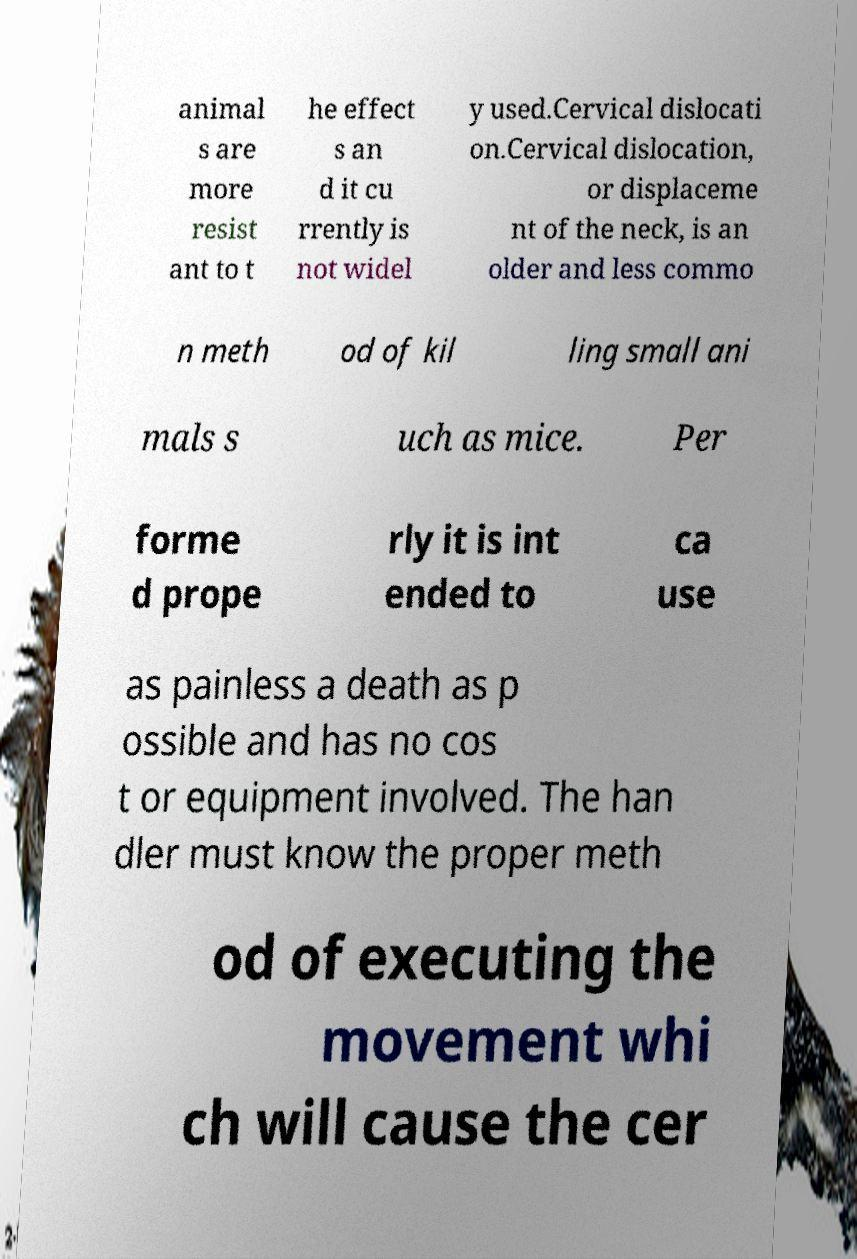I need the written content from this picture converted into text. Can you do that? animal s are more resist ant to t he effect s an d it cu rrently is not widel y used.Cervical dislocati on.Cervical dislocation, or displaceme nt of the neck, is an older and less commo n meth od of kil ling small ani mals s uch as mice. Per forme d prope rly it is int ended to ca use as painless a death as p ossible and has no cos t or equipment involved. The han dler must know the proper meth od of executing the movement whi ch will cause the cer 